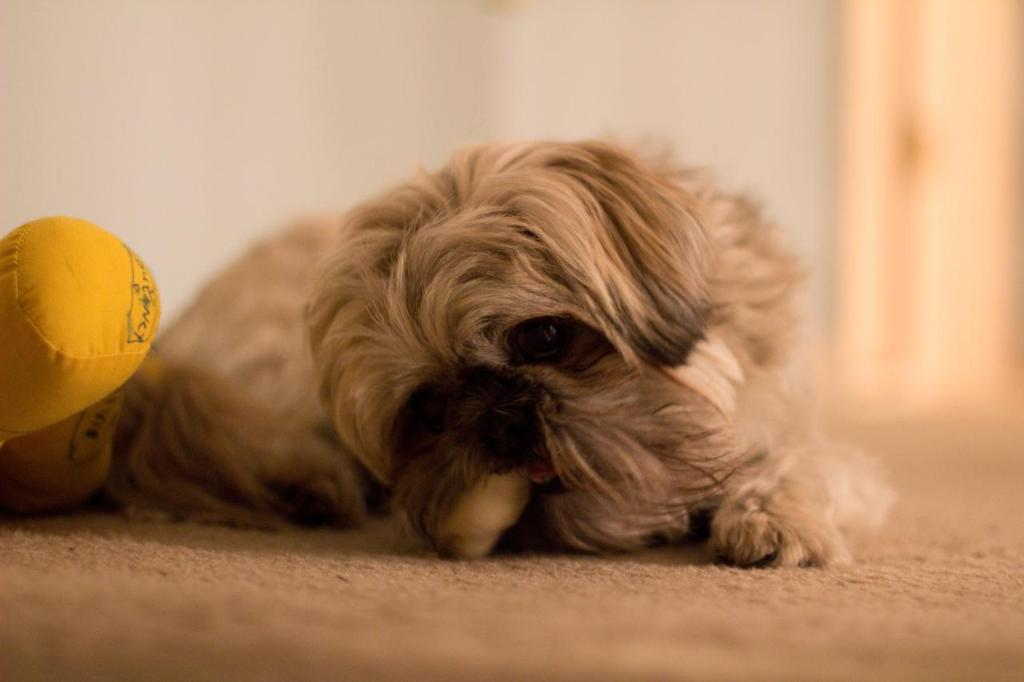What type of animal is present in the image? There is a dog in the image. Can you describe the dog's appearance? The dog is brown in color. What other object is present in the image? There is a doll in the image. Can you describe the doll's appearance? The doll is yellow in color. On which side of the image is the doll located? The doll is on the left side of the image. What substance is the dog using to play with the doll in the image? There is no substance present in the image, and the dog is not playing with the doll. 